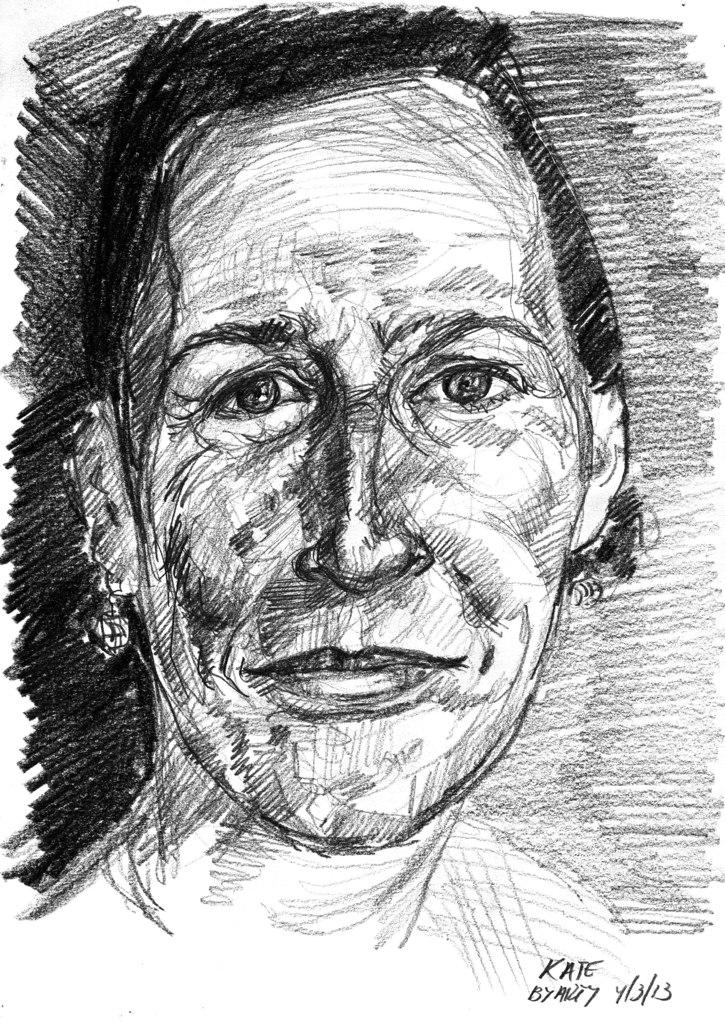What is the main subject of the image? The main subject of the image is an art of a person. Can you describe any additional elements in the image? Yes, there is text in the bottom right corner of the image. What type of hammer is being used by the person in the image? There is no hammer present in the image; it features an art of a person and text in the bottom right corner. 